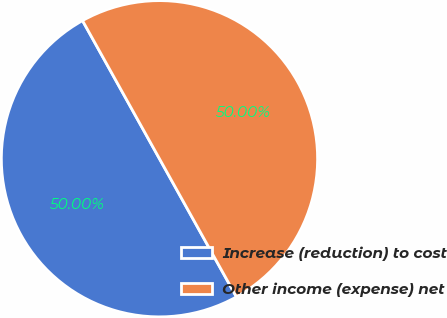Convert chart. <chart><loc_0><loc_0><loc_500><loc_500><pie_chart><fcel>Increase (reduction) to cost<fcel>Other income (expense) net<nl><fcel>50.0%<fcel>50.0%<nl></chart> 